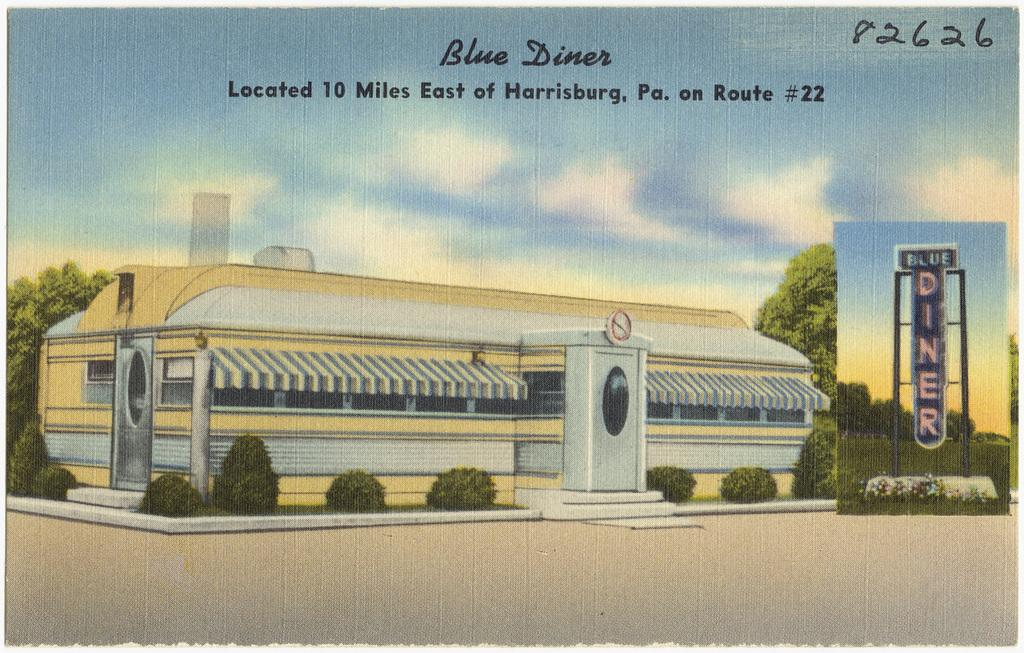<image>
Summarize the visual content of the image. A post card of the Blue Diner in Harrisburg, PA. 